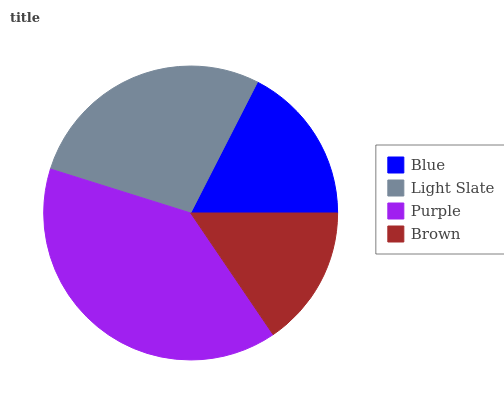Is Brown the minimum?
Answer yes or no. Yes. Is Purple the maximum?
Answer yes or no. Yes. Is Light Slate the minimum?
Answer yes or no. No. Is Light Slate the maximum?
Answer yes or no. No. Is Light Slate greater than Blue?
Answer yes or no. Yes. Is Blue less than Light Slate?
Answer yes or no. Yes. Is Blue greater than Light Slate?
Answer yes or no. No. Is Light Slate less than Blue?
Answer yes or no. No. Is Light Slate the high median?
Answer yes or no. Yes. Is Blue the low median?
Answer yes or no. Yes. Is Blue the high median?
Answer yes or no. No. Is Brown the low median?
Answer yes or no. No. 